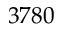Convert formula to latex. <formula><loc_0><loc_0><loc_500><loc_500>3 7 8 0</formula> 